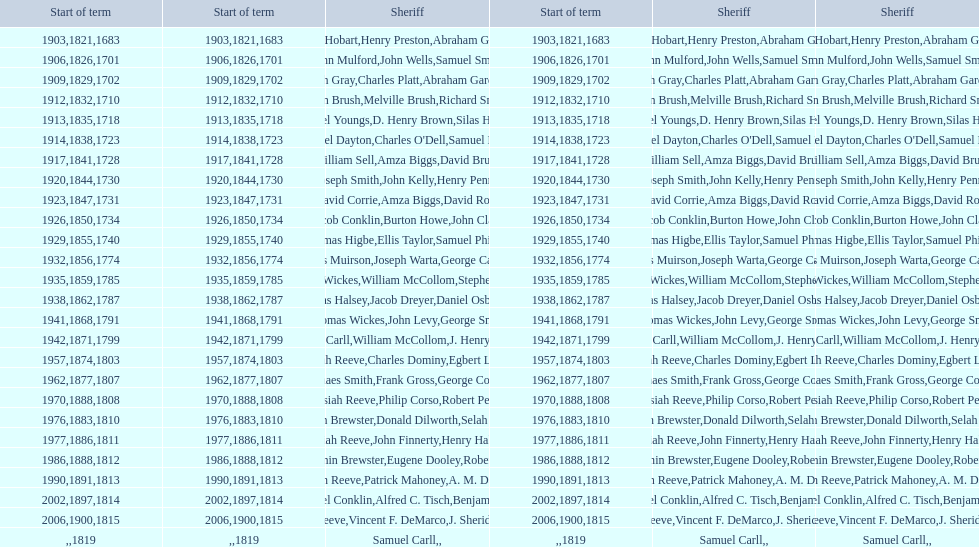What is the total number of sheriffs that were in office in suffolk county between 1903 and 1957? 17. 